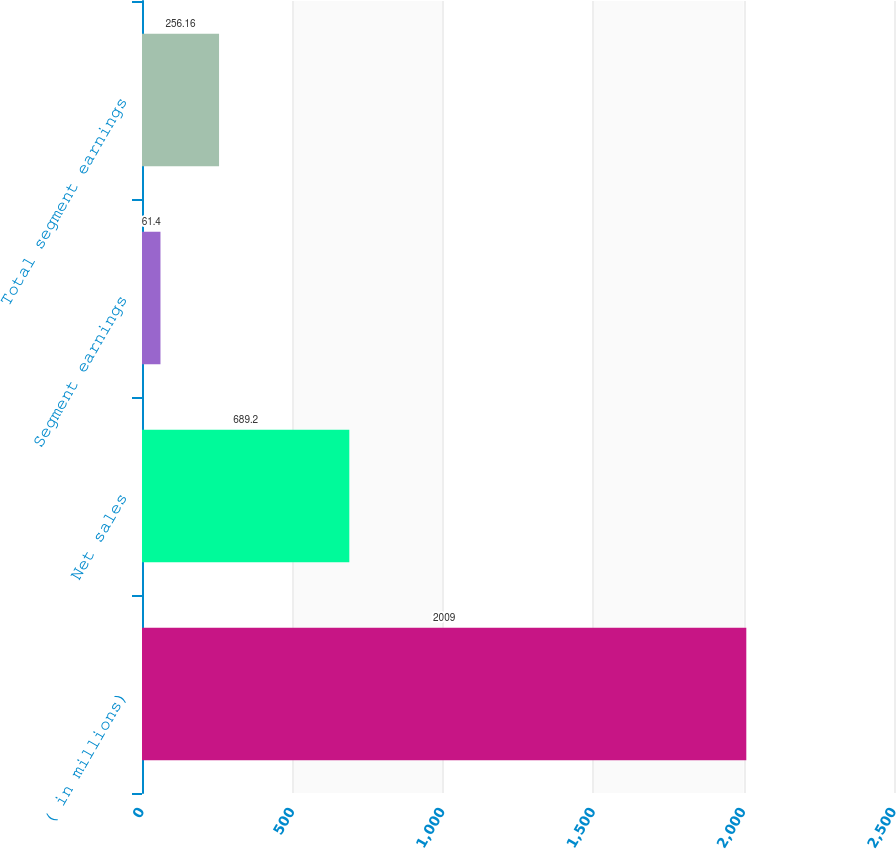Convert chart. <chart><loc_0><loc_0><loc_500><loc_500><bar_chart><fcel>( in millions)<fcel>Net sales<fcel>Segment earnings<fcel>Total segment earnings<nl><fcel>2009<fcel>689.2<fcel>61.4<fcel>256.16<nl></chart> 